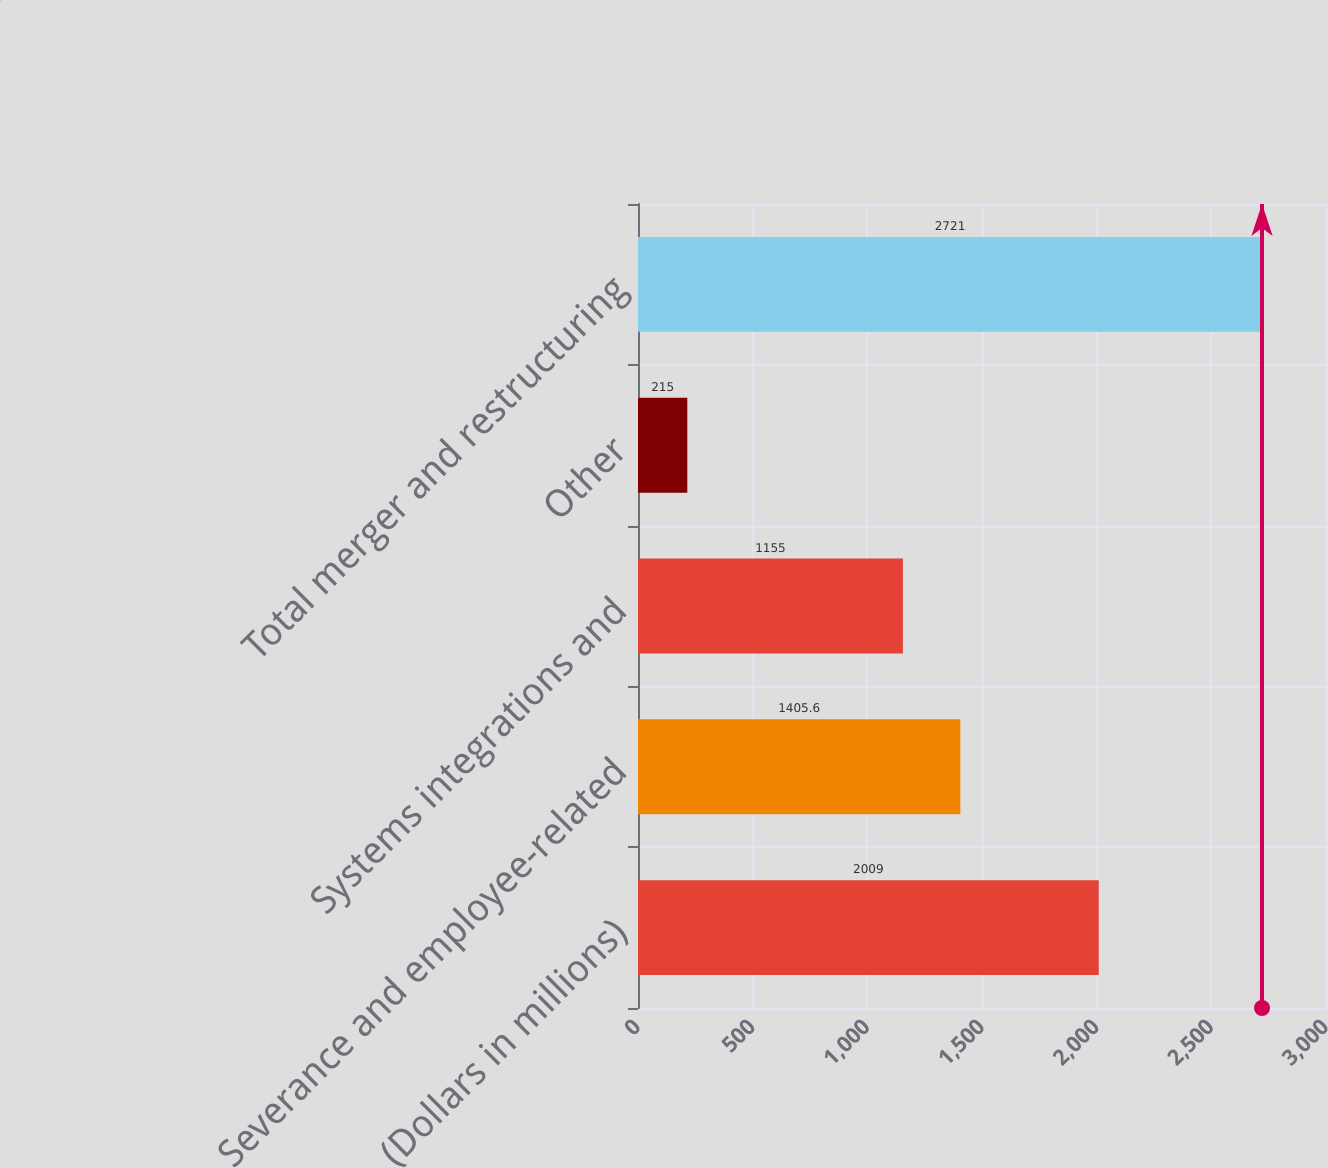Convert chart. <chart><loc_0><loc_0><loc_500><loc_500><bar_chart><fcel>(Dollars in millions)<fcel>Severance and employee-related<fcel>Systems integrations and<fcel>Other<fcel>Total merger and restructuring<nl><fcel>2009<fcel>1405.6<fcel>1155<fcel>215<fcel>2721<nl></chart> 